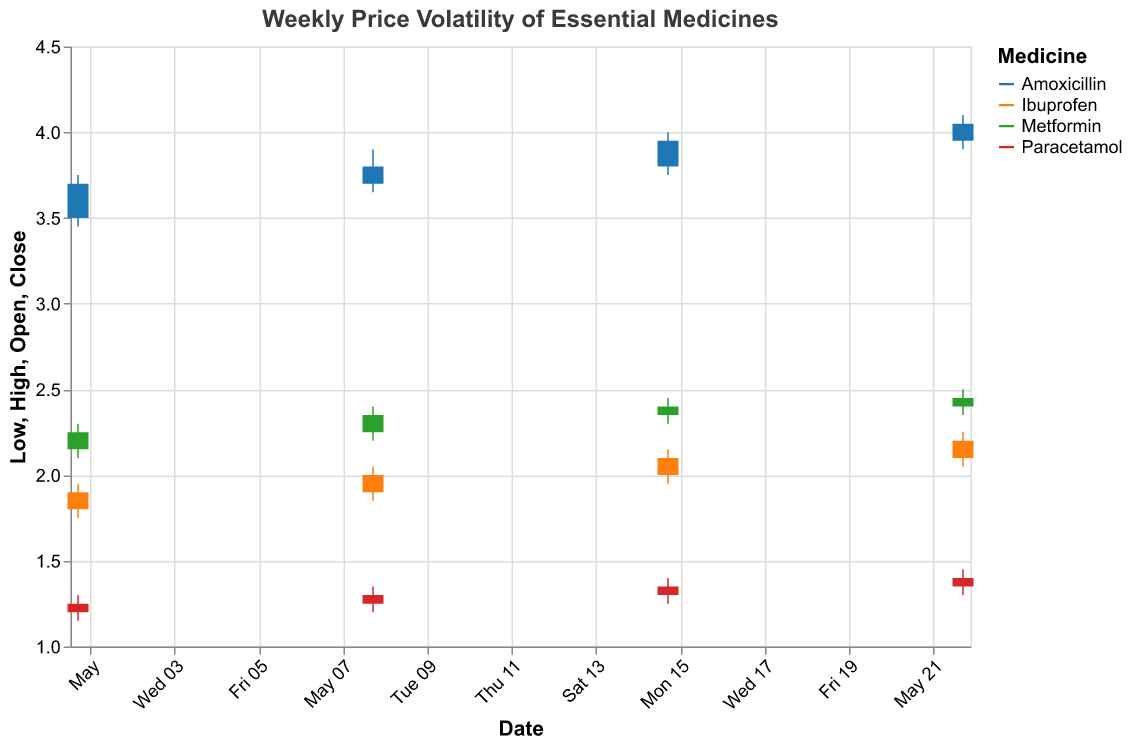What is the title of the figure? The title is displayed at the top of the figure, which clearly states the main topic being visualized.
Answer: Weekly Price Volatility of Essential Medicines Which medicine had the highest closing price on May 15, 2023? Look at the "Close" values for all medicines dated May 15, 2023, and compare them. Amoxicillin has the highest closing price of 3.95.
Answer: Amoxicillin What is the color used to represent Ibuprofen in the chart? Refer to the color legend provided in the figure to identify the color corresponding to Ibuprofen.
Answer: One of the category10 colors (the specific color may vary) Which week shows the highest price volatility for Metformin? Determine the price volatility by calculating the difference between the "High" and "Low" values for each week for Metformin. The week of May 22, 2023, has the highest volatility with a range of 0.15 (2.50 - 2.35).
Answer: Week of May 22, 2023 What is the average closing price of Paracetamol over the four weeks? Sum the closing prices of Paracetamol for the four weeks and divide by 4. The closing prices are 1.25, 1.30, 1.35, and 1.40. The average is (1.25 + 1.30 + 1.35 + 1.40) / 4 = 1.325.
Answer: 1.325 How does the closing price of Amoxicillin on May 01, 2023, compare to its closing price on May 22, 2023? Compare the closing prices of Amoxicillin on the two dates. On May 01, it is 3.70 and on May 22, it is 4.05. The closing price on May 22 is higher.
Answer: It is higher on May 22, 2023 What is the range of prices for Ibuprofen on May 08, 2023? Determine the range by subtracting the "Low" value from the "High" value for Ibuprofen on May 08, 2023. The range is 2.05 - 1.85, which is 0.20.
Answer: 0.20 Which medicine had the least price volatility on May 15, 2023? Calculate the volatility for each medicine on May 15, 2023 (High - Low), and find the smallest value. Paracetamol has the least volatility with a range of 0.15 (1.40 - 1.25 = 0.15).
Answer: Paracetamol What is the closing price trend of Metformin over the four weeks? Look at the closing prices of Metformin for the four weeks and describe the trend. The prices are 2.25, 2.35, 2.40, 2.45, showing a generally upward trend.
Answer: Generally upward 